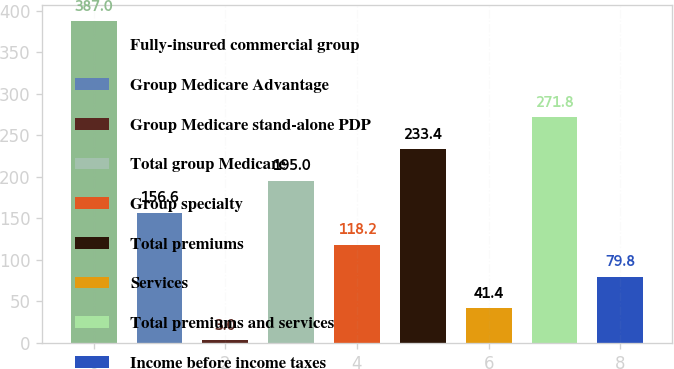Convert chart. <chart><loc_0><loc_0><loc_500><loc_500><bar_chart><fcel>Fully-insured commercial group<fcel>Group Medicare Advantage<fcel>Group Medicare stand-alone PDP<fcel>Total group Medicare<fcel>Group specialty<fcel>Total premiums<fcel>Services<fcel>Total premiums and services<fcel>Income before income taxes<nl><fcel>387<fcel>156.6<fcel>3<fcel>195<fcel>118.2<fcel>233.4<fcel>41.4<fcel>271.8<fcel>79.8<nl></chart> 